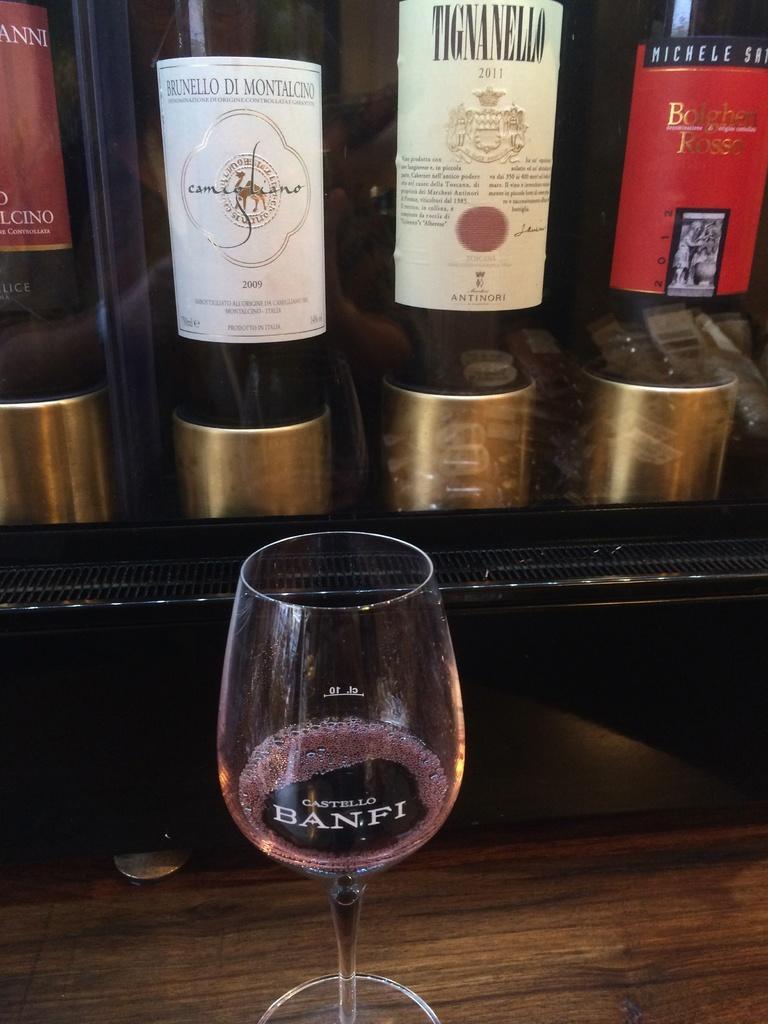Could you give a brief overview of what you see in this image? In this picture, we can see a table, on that table, we can see a wine glass. In the background, we can see some hoardings. 